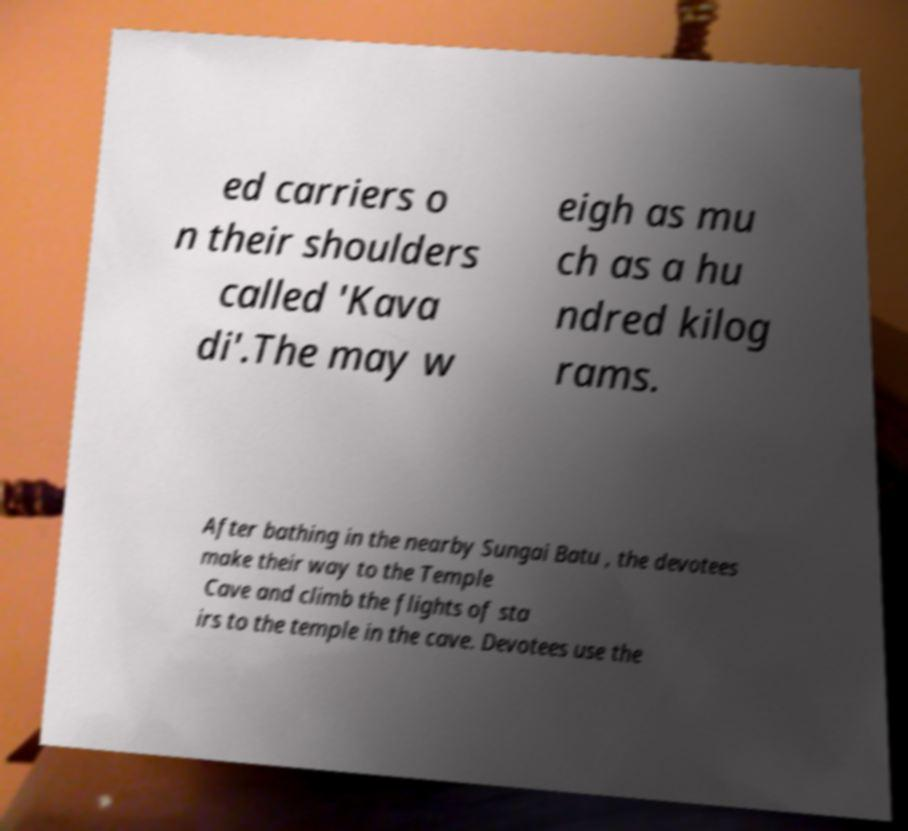Could you extract and type out the text from this image? ed carriers o n their shoulders called 'Kava di'.The may w eigh as mu ch as a hu ndred kilog rams. After bathing in the nearby Sungai Batu , the devotees make their way to the Temple Cave and climb the flights of sta irs to the temple in the cave. Devotees use the 